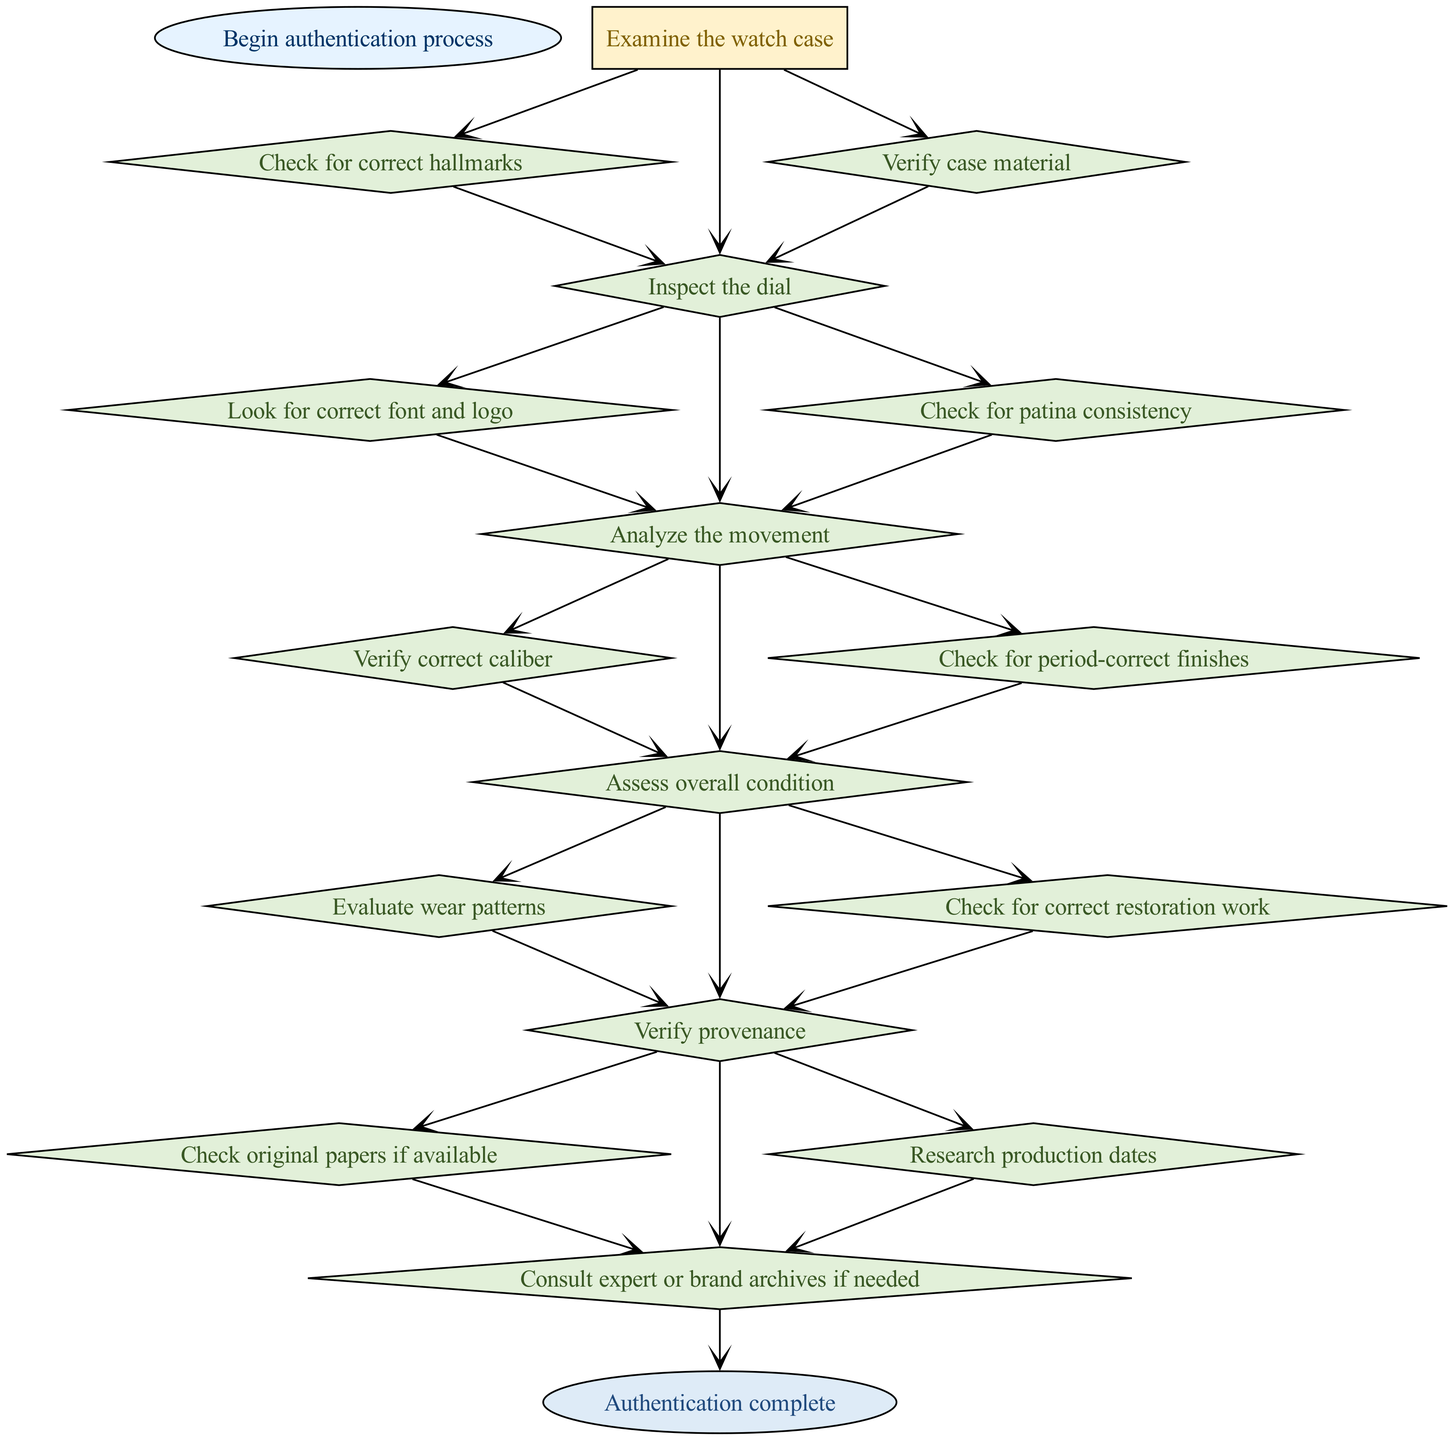What is the first step in the authentication process? The first step in the process, indicated by the starting point of the flowchart, is "Examine the watch case."
Answer: Examine the watch case How many steps are there in the diagram? Counting all unique nodes in the steps, there are six main authentication steps plus the start and end nodes, making it a total of eight nodes.
Answer: Eight What follows after checking for correct hallmarks? The flow indicates that checking for correct hallmarks (step 1a) leads to the next step, "Inspect the dial," as it continues the process outlined in the diagram.
Answer: Inspect the dial What is the last step before consulting an expert? The final step before consulting an expert is "Verify provenance," which includes checking original papers and researching production dates.
Answer: Verify provenance Which attribute is checked during the movement analysis? During the movement analysis stage (step 3), the key attribute checked is the "correct caliber," as outlined in the flow sequence connecting that step.
Answer: Correct caliber How does the flowchart visually represent a decision point? The decision points in the flowchart are represented as diamonds, such as those found in steps 1, 2, 3, and 4, where multiple options branch out from each node.
Answer: Diamonds Which step shows the evaluation of wear patterns? "Assess overall condition" (step 4) specifically highlights the evaluation of wear patterns as a child step leading towards verifying provenance.
Answer: Assess overall condition What color represents the start node? The start node is colored in light blue (#E6F3FF), distinguishing it visually from the other steps and marking the beginning of the authentication process.
Answer: Light blue 